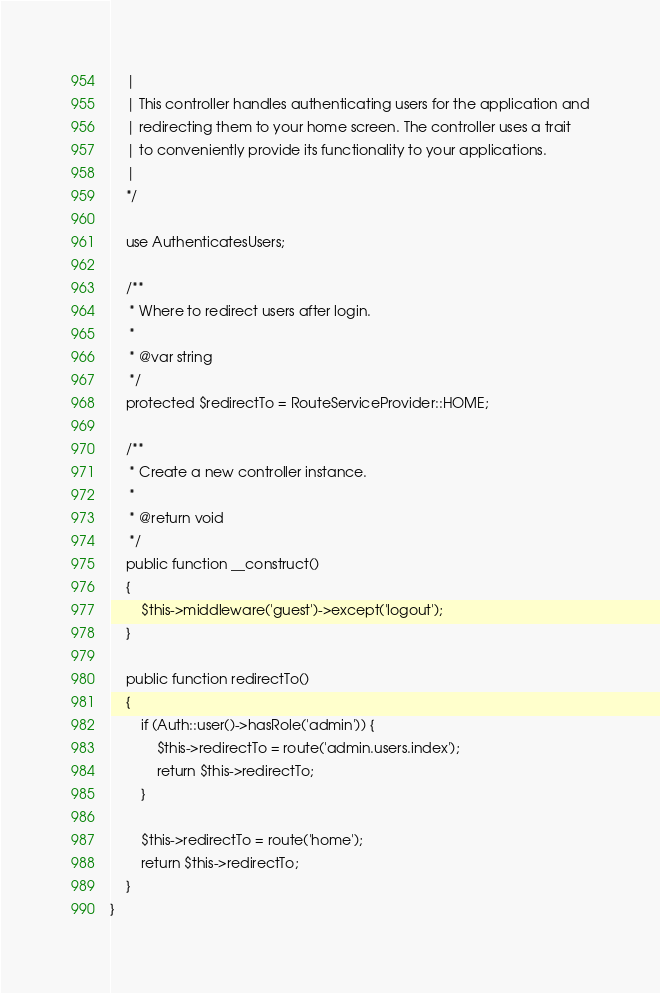Convert code to text. <code><loc_0><loc_0><loc_500><loc_500><_PHP_>    |
    | This controller handles authenticating users for the application and
    | redirecting them to your home screen. The controller uses a trait
    | to conveniently provide its functionality to your applications.
    |
    */

    use AuthenticatesUsers;

    /**
     * Where to redirect users after login.
     *
     * @var string
     */
    protected $redirectTo = RouteServiceProvider::HOME;

    /**
     * Create a new controller instance.
     *
     * @return void
     */
    public function __construct()
    {
        $this->middleware('guest')->except('logout');
    }

    public function redirectTo()
    {
        if (Auth::user()->hasRole('admin')) {
            $this->redirectTo = route('admin.users.index');
            return $this->redirectTo;
        }

        $this->redirectTo = route('home');
        return $this->redirectTo;
    }
}
</code> 